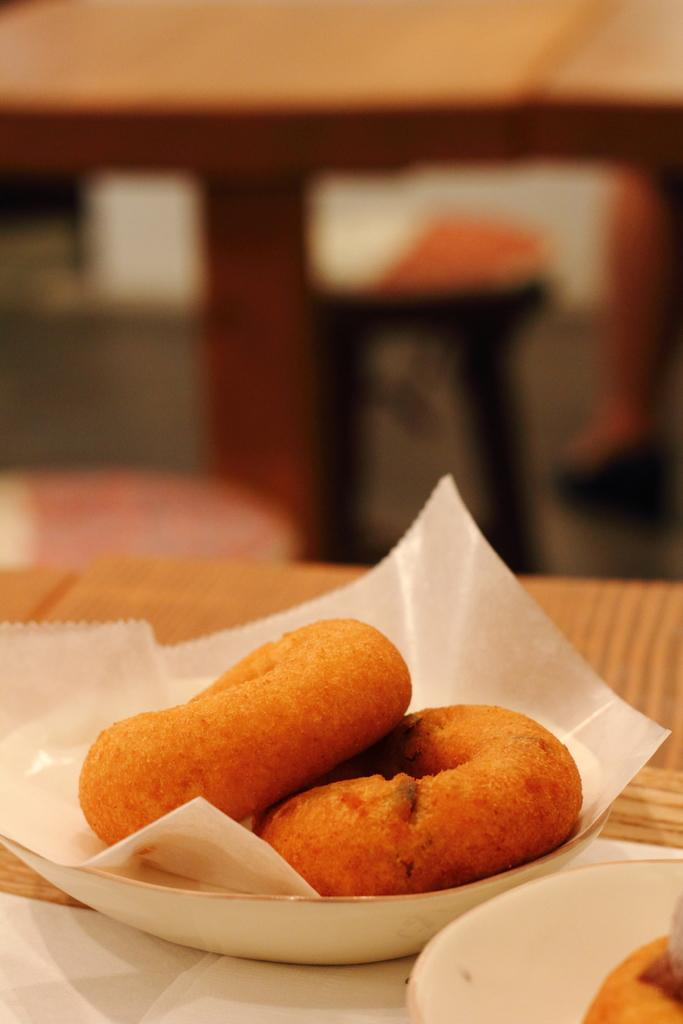What types of objects can be seen in the image? There are food items and plates in the image. What is placed on the plates? The plates have papers on them. Can you describe the background of the image? The background of the image is blurred. What type of picture is hanging on the wall in the image? There is no picture hanging on the wall in the image; the background is blurred. Can you describe the office setting in the image? There is no office setting present in the image; it does not depict an office environment. 